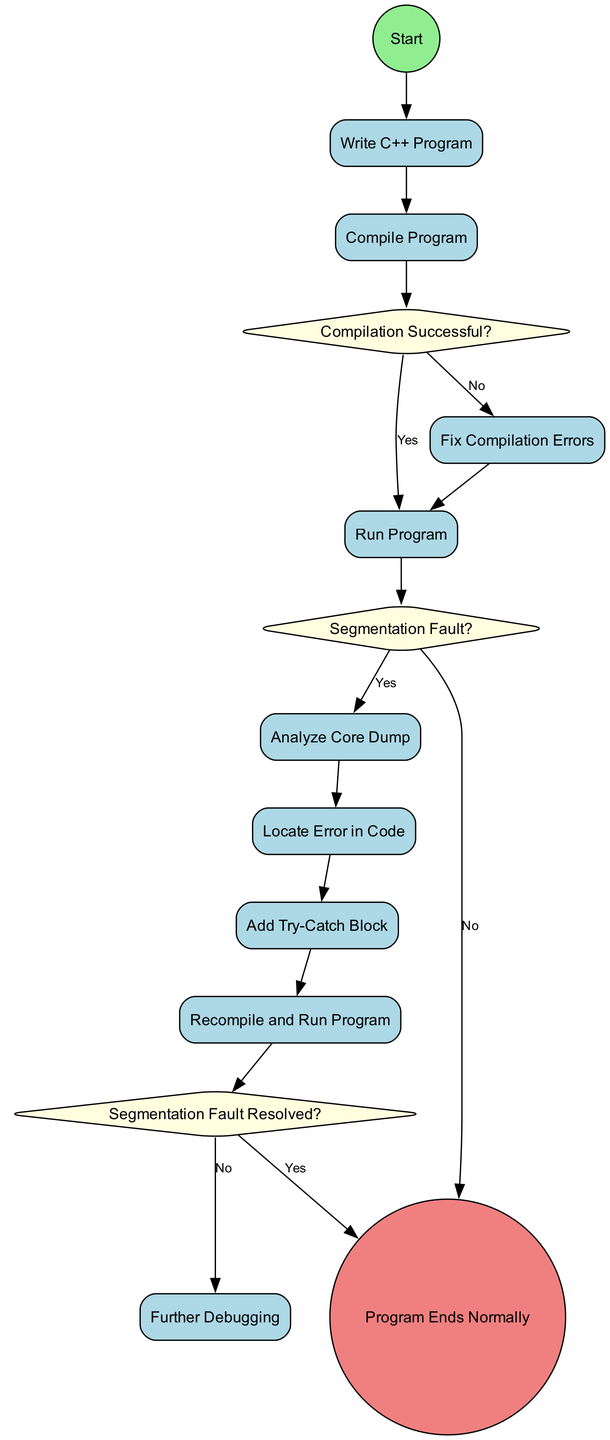What is the starting event of the diagram? The diagram begins with a start event labeled "Start". This can be identified at the top of the diagram.
Answer: Start How many decision points are present in the diagram? There are three decision points in the diagram: "Compilation Successful?", "Segmentation Fault?", and "Segmentation Fault Resolved?". By counting these decision nodes, we find the total.
Answer: 3 What action follows after fixing compilation errors? After fixing compilation errors, the next action is "Run Program". This can be traced by following the flow after the "Fix Compilation Errors" node.
Answer: Run Program What happens if there is a segmentation fault? If there is a segmentation fault, the flow goes to "Analyze Core Dump". This is indicated by following the "Yes" branch from the "Segmentation Fault?" decision point.
Answer: Analyze Core Dump What do you add to handle segmentation faults? You add "Try-Catch Block" to handle segmentation faults, as indicated after the "Locate Error in Code" step.
Answer: Try-Catch Block What is the final event of the diagram? The final event of the diagram is "Program Ends Normally", which is indicated as the end event. It appears at the bottom of the flow after resolving the segmentation fault or further debugging.
Answer: Program Ends Normally What action is taken if the segmentation fault is not resolved? If the segmentation fault is not resolved, the subsequent action is "Further Debugging". This occurs following the "No" branch of the "Segmentation Fault Resolved?" decision.
Answer: Further Debugging How many total actions are taken in the diagram? There are ten actions in the diagram: "Write C++ Program", "Compile Program", "Fix Compilation Errors", "Run Program", "Analyze Core Dump", "Locate Error in Code", "Add Try-Catch Block", "Recompile and Run Program", "Further Debugging", and "Program Ends Normally". Counting each listed action provides the total.
Answer: 10 What is the result if the compilation is successful? If the compilation is successful, the flow proceeds to "Run Program". This can be determined from the "Yes" branch of the "Compilation Successful?" decision.
Answer: Run Program 